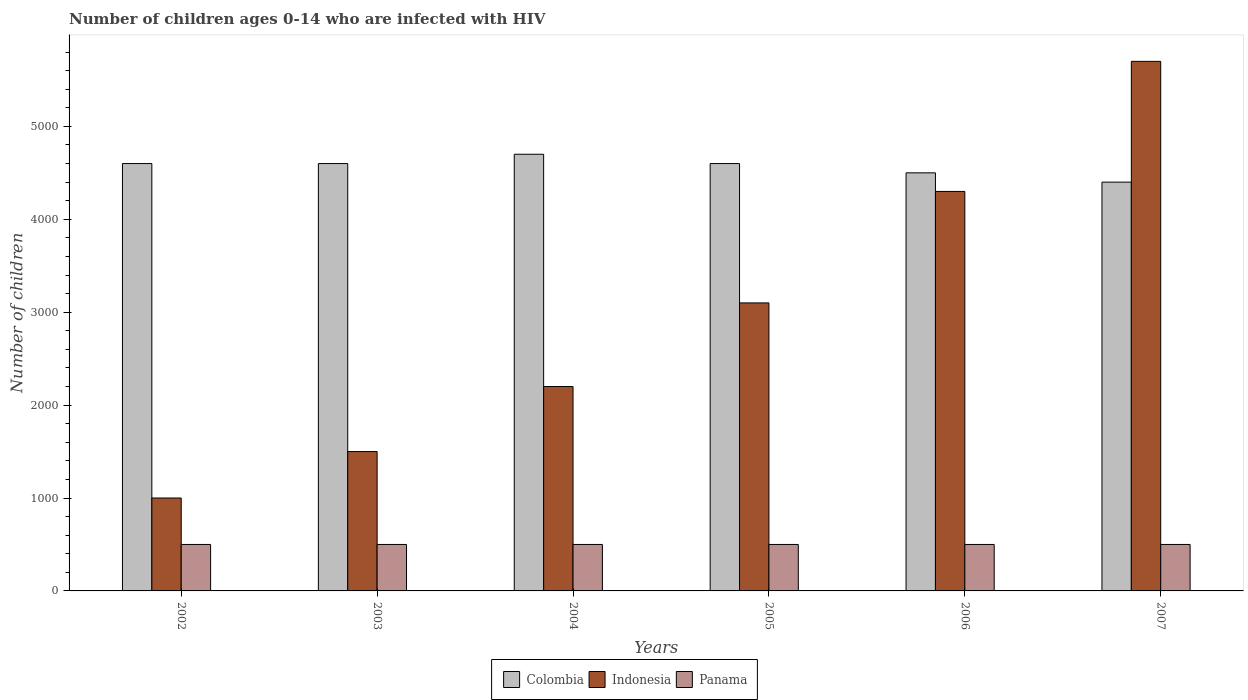How many groups of bars are there?
Your response must be concise. 6. Are the number of bars on each tick of the X-axis equal?
Give a very brief answer. Yes. How many bars are there on the 2nd tick from the right?
Provide a short and direct response. 3. What is the label of the 3rd group of bars from the left?
Ensure brevity in your answer.  2004. What is the number of HIV infected children in Indonesia in 2004?
Keep it short and to the point. 2200. Across all years, what is the maximum number of HIV infected children in Colombia?
Offer a very short reply. 4700. Across all years, what is the minimum number of HIV infected children in Indonesia?
Your answer should be very brief. 1000. In which year was the number of HIV infected children in Panama maximum?
Your answer should be very brief. 2002. What is the total number of HIV infected children in Colombia in the graph?
Offer a very short reply. 2.74e+04. What is the difference between the number of HIV infected children in Panama in 2005 and the number of HIV infected children in Indonesia in 2006?
Give a very brief answer. -3800. What is the average number of HIV infected children in Indonesia per year?
Ensure brevity in your answer.  2966.67. In the year 2003, what is the difference between the number of HIV infected children in Colombia and number of HIV infected children in Indonesia?
Your response must be concise. 3100. In how many years, is the number of HIV infected children in Indonesia greater than 400?
Provide a short and direct response. 6. Is the difference between the number of HIV infected children in Colombia in 2003 and 2007 greater than the difference between the number of HIV infected children in Indonesia in 2003 and 2007?
Offer a very short reply. Yes. What is the difference between the highest and the second highest number of HIV infected children in Indonesia?
Provide a short and direct response. 1400. What is the difference between the highest and the lowest number of HIV infected children in Indonesia?
Provide a succinct answer. 4700. In how many years, is the number of HIV infected children in Colombia greater than the average number of HIV infected children in Colombia taken over all years?
Offer a very short reply. 4. Is it the case that in every year, the sum of the number of HIV infected children in Indonesia and number of HIV infected children in Panama is greater than the number of HIV infected children in Colombia?
Provide a succinct answer. No. How many years are there in the graph?
Provide a succinct answer. 6. What is the difference between two consecutive major ticks on the Y-axis?
Your answer should be very brief. 1000. Are the values on the major ticks of Y-axis written in scientific E-notation?
Give a very brief answer. No. Does the graph contain any zero values?
Make the answer very short. No. Does the graph contain grids?
Provide a short and direct response. No. Where does the legend appear in the graph?
Ensure brevity in your answer.  Bottom center. What is the title of the graph?
Make the answer very short. Number of children ages 0-14 who are infected with HIV. Does "Uzbekistan" appear as one of the legend labels in the graph?
Make the answer very short. No. What is the label or title of the X-axis?
Make the answer very short. Years. What is the label or title of the Y-axis?
Your answer should be very brief. Number of children. What is the Number of children in Colombia in 2002?
Provide a short and direct response. 4600. What is the Number of children of Panama in 2002?
Your response must be concise. 500. What is the Number of children in Colombia in 2003?
Offer a terse response. 4600. What is the Number of children in Indonesia in 2003?
Your response must be concise. 1500. What is the Number of children in Colombia in 2004?
Your answer should be compact. 4700. What is the Number of children of Indonesia in 2004?
Provide a succinct answer. 2200. What is the Number of children of Colombia in 2005?
Your answer should be compact. 4600. What is the Number of children in Indonesia in 2005?
Your answer should be compact. 3100. What is the Number of children of Panama in 2005?
Provide a short and direct response. 500. What is the Number of children in Colombia in 2006?
Your answer should be compact. 4500. What is the Number of children in Indonesia in 2006?
Your answer should be very brief. 4300. What is the Number of children in Colombia in 2007?
Make the answer very short. 4400. What is the Number of children in Indonesia in 2007?
Your answer should be very brief. 5700. What is the Number of children of Panama in 2007?
Make the answer very short. 500. Across all years, what is the maximum Number of children of Colombia?
Make the answer very short. 4700. Across all years, what is the maximum Number of children of Indonesia?
Offer a very short reply. 5700. Across all years, what is the maximum Number of children of Panama?
Provide a succinct answer. 500. Across all years, what is the minimum Number of children of Colombia?
Your answer should be very brief. 4400. What is the total Number of children in Colombia in the graph?
Make the answer very short. 2.74e+04. What is the total Number of children of Indonesia in the graph?
Give a very brief answer. 1.78e+04. What is the total Number of children of Panama in the graph?
Give a very brief answer. 3000. What is the difference between the Number of children of Colombia in 2002 and that in 2003?
Provide a short and direct response. 0. What is the difference between the Number of children of Indonesia in 2002 and that in 2003?
Make the answer very short. -500. What is the difference between the Number of children of Panama in 2002 and that in 2003?
Ensure brevity in your answer.  0. What is the difference between the Number of children of Colombia in 2002 and that in 2004?
Make the answer very short. -100. What is the difference between the Number of children in Indonesia in 2002 and that in 2004?
Make the answer very short. -1200. What is the difference between the Number of children in Indonesia in 2002 and that in 2005?
Your answer should be very brief. -2100. What is the difference between the Number of children in Indonesia in 2002 and that in 2006?
Ensure brevity in your answer.  -3300. What is the difference between the Number of children in Panama in 2002 and that in 2006?
Provide a succinct answer. 0. What is the difference between the Number of children of Colombia in 2002 and that in 2007?
Provide a succinct answer. 200. What is the difference between the Number of children in Indonesia in 2002 and that in 2007?
Provide a succinct answer. -4700. What is the difference between the Number of children in Colombia in 2003 and that in 2004?
Provide a succinct answer. -100. What is the difference between the Number of children in Indonesia in 2003 and that in 2004?
Your response must be concise. -700. What is the difference between the Number of children in Panama in 2003 and that in 2004?
Provide a succinct answer. 0. What is the difference between the Number of children in Indonesia in 2003 and that in 2005?
Keep it short and to the point. -1600. What is the difference between the Number of children of Colombia in 2003 and that in 2006?
Your answer should be very brief. 100. What is the difference between the Number of children in Indonesia in 2003 and that in 2006?
Make the answer very short. -2800. What is the difference between the Number of children in Panama in 2003 and that in 2006?
Provide a succinct answer. 0. What is the difference between the Number of children of Indonesia in 2003 and that in 2007?
Provide a succinct answer. -4200. What is the difference between the Number of children of Indonesia in 2004 and that in 2005?
Make the answer very short. -900. What is the difference between the Number of children in Colombia in 2004 and that in 2006?
Your answer should be compact. 200. What is the difference between the Number of children of Indonesia in 2004 and that in 2006?
Provide a succinct answer. -2100. What is the difference between the Number of children in Panama in 2004 and that in 2006?
Ensure brevity in your answer.  0. What is the difference between the Number of children in Colombia in 2004 and that in 2007?
Offer a terse response. 300. What is the difference between the Number of children in Indonesia in 2004 and that in 2007?
Keep it short and to the point. -3500. What is the difference between the Number of children in Panama in 2004 and that in 2007?
Keep it short and to the point. 0. What is the difference between the Number of children in Indonesia in 2005 and that in 2006?
Keep it short and to the point. -1200. What is the difference between the Number of children in Colombia in 2005 and that in 2007?
Your response must be concise. 200. What is the difference between the Number of children of Indonesia in 2005 and that in 2007?
Keep it short and to the point. -2600. What is the difference between the Number of children of Panama in 2005 and that in 2007?
Keep it short and to the point. 0. What is the difference between the Number of children of Indonesia in 2006 and that in 2007?
Your answer should be very brief. -1400. What is the difference between the Number of children in Panama in 2006 and that in 2007?
Give a very brief answer. 0. What is the difference between the Number of children in Colombia in 2002 and the Number of children in Indonesia in 2003?
Keep it short and to the point. 3100. What is the difference between the Number of children in Colombia in 2002 and the Number of children in Panama in 2003?
Give a very brief answer. 4100. What is the difference between the Number of children in Colombia in 2002 and the Number of children in Indonesia in 2004?
Ensure brevity in your answer.  2400. What is the difference between the Number of children in Colombia in 2002 and the Number of children in Panama in 2004?
Provide a succinct answer. 4100. What is the difference between the Number of children in Colombia in 2002 and the Number of children in Indonesia in 2005?
Offer a very short reply. 1500. What is the difference between the Number of children in Colombia in 2002 and the Number of children in Panama in 2005?
Your answer should be compact. 4100. What is the difference between the Number of children of Colombia in 2002 and the Number of children of Indonesia in 2006?
Offer a very short reply. 300. What is the difference between the Number of children in Colombia in 2002 and the Number of children in Panama in 2006?
Your response must be concise. 4100. What is the difference between the Number of children of Colombia in 2002 and the Number of children of Indonesia in 2007?
Keep it short and to the point. -1100. What is the difference between the Number of children of Colombia in 2002 and the Number of children of Panama in 2007?
Your response must be concise. 4100. What is the difference between the Number of children in Colombia in 2003 and the Number of children in Indonesia in 2004?
Your response must be concise. 2400. What is the difference between the Number of children in Colombia in 2003 and the Number of children in Panama in 2004?
Ensure brevity in your answer.  4100. What is the difference between the Number of children of Indonesia in 2003 and the Number of children of Panama in 2004?
Your response must be concise. 1000. What is the difference between the Number of children of Colombia in 2003 and the Number of children of Indonesia in 2005?
Give a very brief answer. 1500. What is the difference between the Number of children of Colombia in 2003 and the Number of children of Panama in 2005?
Offer a terse response. 4100. What is the difference between the Number of children in Indonesia in 2003 and the Number of children in Panama in 2005?
Offer a very short reply. 1000. What is the difference between the Number of children in Colombia in 2003 and the Number of children in Indonesia in 2006?
Your answer should be very brief. 300. What is the difference between the Number of children in Colombia in 2003 and the Number of children in Panama in 2006?
Provide a short and direct response. 4100. What is the difference between the Number of children of Indonesia in 2003 and the Number of children of Panama in 2006?
Make the answer very short. 1000. What is the difference between the Number of children in Colombia in 2003 and the Number of children in Indonesia in 2007?
Your response must be concise. -1100. What is the difference between the Number of children in Colombia in 2003 and the Number of children in Panama in 2007?
Give a very brief answer. 4100. What is the difference between the Number of children of Indonesia in 2003 and the Number of children of Panama in 2007?
Provide a short and direct response. 1000. What is the difference between the Number of children of Colombia in 2004 and the Number of children of Indonesia in 2005?
Make the answer very short. 1600. What is the difference between the Number of children in Colombia in 2004 and the Number of children in Panama in 2005?
Provide a short and direct response. 4200. What is the difference between the Number of children of Indonesia in 2004 and the Number of children of Panama in 2005?
Your response must be concise. 1700. What is the difference between the Number of children in Colombia in 2004 and the Number of children in Panama in 2006?
Ensure brevity in your answer.  4200. What is the difference between the Number of children in Indonesia in 2004 and the Number of children in Panama in 2006?
Offer a terse response. 1700. What is the difference between the Number of children of Colombia in 2004 and the Number of children of Indonesia in 2007?
Give a very brief answer. -1000. What is the difference between the Number of children of Colombia in 2004 and the Number of children of Panama in 2007?
Keep it short and to the point. 4200. What is the difference between the Number of children of Indonesia in 2004 and the Number of children of Panama in 2007?
Your response must be concise. 1700. What is the difference between the Number of children in Colombia in 2005 and the Number of children in Indonesia in 2006?
Ensure brevity in your answer.  300. What is the difference between the Number of children of Colombia in 2005 and the Number of children of Panama in 2006?
Give a very brief answer. 4100. What is the difference between the Number of children of Indonesia in 2005 and the Number of children of Panama in 2006?
Provide a short and direct response. 2600. What is the difference between the Number of children of Colombia in 2005 and the Number of children of Indonesia in 2007?
Offer a very short reply. -1100. What is the difference between the Number of children of Colombia in 2005 and the Number of children of Panama in 2007?
Your answer should be compact. 4100. What is the difference between the Number of children of Indonesia in 2005 and the Number of children of Panama in 2007?
Your response must be concise. 2600. What is the difference between the Number of children of Colombia in 2006 and the Number of children of Indonesia in 2007?
Ensure brevity in your answer.  -1200. What is the difference between the Number of children of Colombia in 2006 and the Number of children of Panama in 2007?
Provide a short and direct response. 4000. What is the difference between the Number of children of Indonesia in 2006 and the Number of children of Panama in 2007?
Your answer should be very brief. 3800. What is the average Number of children of Colombia per year?
Keep it short and to the point. 4566.67. What is the average Number of children of Indonesia per year?
Your answer should be very brief. 2966.67. In the year 2002, what is the difference between the Number of children of Colombia and Number of children of Indonesia?
Offer a terse response. 3600. In the year 2002, what is the difference between the Number of children in Colombia and Number of children in Panama?
Your answer should be very brief. 4100. In the year 2002, what is the difference between the Number of children of Indonesia and Number of children of Panama?
Ensure brevity in your answer.  500. In the year 2003, what is the difference between the Number of children of Colombia and Number of children of Indonesia?
Your response must be concise. 3100. In the year 2003, what is the difference between the Number of children of Colombia and Number of children of Panama?
Provide a short and direct response. 4100. In the year 2004, what is the difference between the Number of children in Colombia and Number of children in Indonesia?
Your answer should be compact. 2500. In the year 2004, what is the difference between the Number of children of Colombia and Number of children of Panama?
Keep it short and to the point. 4200. In the year 2004, what is the difference between the Number of children in Indonesia and Number of children in Panama?
Offer a very short reply. 1700. In the year 2005, what is the difference between the Number of children in Colombia and Number of children in Indonesia?
Offer a terse response. 1500. In the year 2005, what is the difference between the Number of children in Colombia and Number of children in Panama?
Offer a very short reply. 4100. In the year 2005, what is the difference between the Number of children of Indonesia and Number of children of Panama?
Provide a succinct answer. 2600. In the year 2006, what is the difference between the Number of children in Colombia and Number of children in Panama?
Offer a very short reply. 4000. In the year 2006, what is the difference between the Number of children in Indonesia and Number of children in Panama?
Provide a short and direct response. 3800. In the year 2007, what is the difference between the Number of children in Colombia and Number of children in Indonesia?
Offer a very short reply. -1300. In the year 2007, what is the difference between the Number of children in Colombia and Number of children in Panama?
Give a very brief answer. 3900. In the year 2007, what is the difference between the Number of children of Indonesia and Number of children of Panama?
Ensure brevity in your answer.  5200. What is the ratio of the Number of children of Colombia in 2002 to that in 2003?
Offer a very short reply. 1. What is the ratio of the Number of children in Colombia in 2002 to that in 2004?
Give a very brief answer. 0.98. What is the ratio of the Number of children of Indonesia in 2002 to that in 2004?
Offer a very short reply. 0.45. What is the ratio of the Number of children of Panama in 2002 to that in 2004?
Keep it short and to the point. 1. What is the ratio of the Number of children of Indonesia in 2002 to that in 2005?
Give a very brief answer. 0.32. What is the ratio of the Number of children of Panama in 2002 to that in 2005?
Give a very brief answer. 1. What is the ratio of the Number of children of Colombia in 2002 to that in 2006?
Keep it short and to the point. 1.02. What is the ratio of the Number of children in Indonesia in 2002 to that in 2006?
Your answer should be very brief. 0.23. What is the ratio of the Number of children of Panama in 2002 to that in 2006?
Your answer should be compact. 1. What is the ratio of the Number of children of Colombia in 2002 to that in 2007?
Give a very brief answer. 1.05. What is the ratio of the Number of children in Indonesia in 2002 to that in 2007?
Give a very brief answer. 0.18. What is the ratio of the Number of children of Colombia in 2003 to that in 2004?
Give a very brief answer. 0.98. What is the ratio of the Number of children in Indonesia in 2003 to that in 2004?
Give a very brief answer. 0.68. What is the ratio of the Number of children of Colombia in 2003 to that in 2005?
Offer a very short reply. 1. What is the ratio of the Number of children in Indonesia in 2003 to that in 2005?
Make the answer very short. 0.48. What is the ratio of the Number of children in Colombia in 2003 to that in 2006?
Offer a terse response. 1.02. What is the ratio of the Number of children of Indonesia in 2003 to that in 2006?
Your answer should be very brief. 0.35. What is the ratio of the Number of children of Panama in 2003 to that in 2006?
Keep it short and to the point. 1. What is the ratio of the Number of children of Colombia in 2003 to that in 2007?
Ensure brevity in your answer.  1.05. What is the ratio of the Number of children in Indonesia in 2003 to that in 2007?
Your answer should be very brief. 0.26. What is the ratio of the Number of children in Colombia in 2004 to that in 2005?
Offer a very short reply. 1.02. What is the ratio of the Number of children of Indonesia in 2004 to that in 2005?
Keep it short and to the point. 0.71. What is the ratio of the Number of children in Panama in 2004 to that in 2005?
Make the answer very short. 1. What is the ratio of the Number of children of Colombia in 2004 to that in 2006?
Provide a succinct answer. 1.04. What is the ratio of the Number of children in Indonesia in 2004 to that in 2006?
Offer a terse response. 0.51. What is the ratio of the Number of children in Panama in 2004 to that in 2006?
Ensure brevity in your answer.  1. What is the ratio of the Number of children in Colombia in 2004 to that in 2007?
Keep it short and to the point. 1.07. What is the ratio of the Number of children in Indonesia in 2004 to that in 2007?
Ensure brevity in your answer.  0.39. What is the ratio of the Number of children of Panama in 2004 to that in 2007?
Offer a terse response. 1. What is the ratio of the Number of children of Colombia in 2005 to that in 2006?
Your answer should be compact. 1.02. What is the ratio of the Number of children in Indonesia in 2005 to that in 2006?
Ensure brevity in your answer.  0.72. What is the ratio of the Number of children of Panama in 2005 to that in 2006?
Your answer should be compact. 1. What is the ratio of the Number of children in Colombia in 2005 to that in 2007?
Your answer should be very brief. 1.05. What is the ratio of the Number of children in Indonesia in 2005 to that in 2007?
Provide a succinct answer. 0.54. What is the ratio of the Number of children of Panama in 2005 to that in 2007?
Your answer should be compact. 1. What is the ratio of the Number of children of Colombia in 2006 to that in 2007?
Provide a succinct answer. 1.02. What is the ratio of the Number of children in Indonesia in 2006 to that in 2007?
Provide a succinct answer. 0.75. What is the ratio of the Number of children in Panama in 2006 to that in 2007?
Offer a terse response. 1. What is the difference between the highest and the second highest Number of children of Colombia?
Your answer should be very brief. 100. What is the difference between the highest and the second highest Number of children of Indonesia?
Ensure brevity in your answer.  1400. What is the difference between the highest and the second highest Number of children in Panama?
Your response must be concise. 0. What is the difference between the highest and the lowest Number of children in Colombia?
Offer a very short reply. 300. What is the difference between the highest and the lowest Number of children of Indonesia?
Your answer should be compact. 4700. What is the difference between the highest and the lowest Number of children in Panama?
Your response must be concise. 0. 